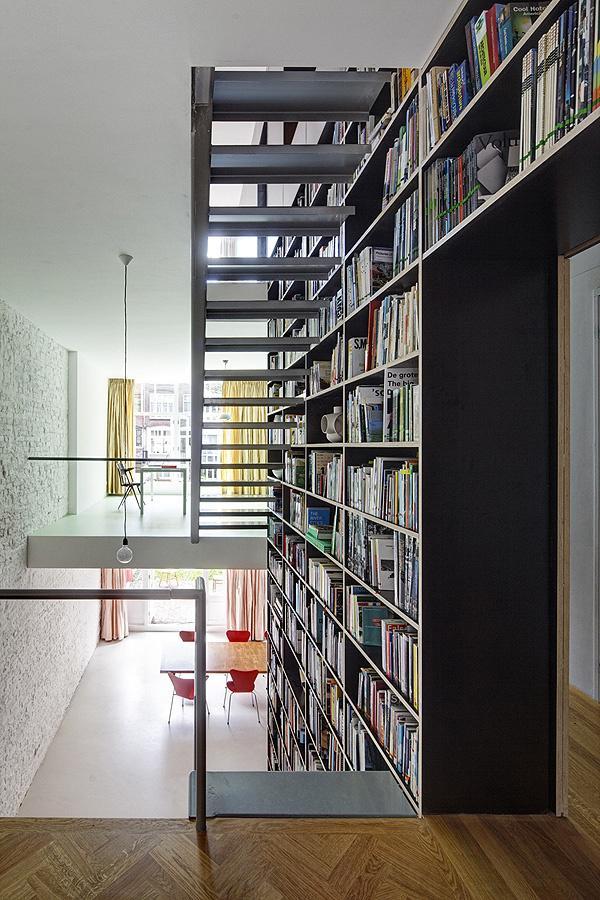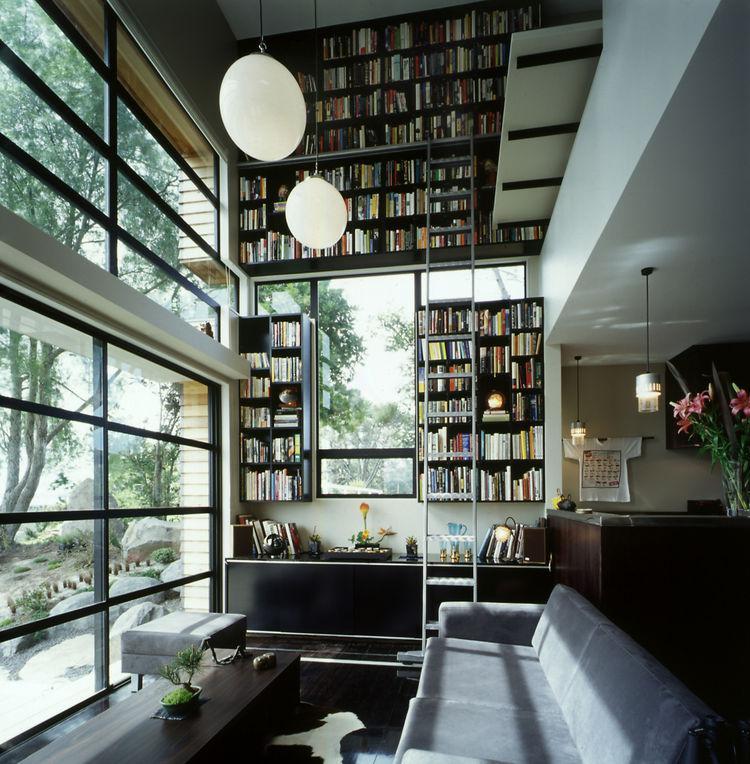The first image is the image on the left, the second image is the image on the right. Assess this claim about the two images: "There is one ladder leaning against a bookcase.". Correct or not? Answer yes or no. Yes. 